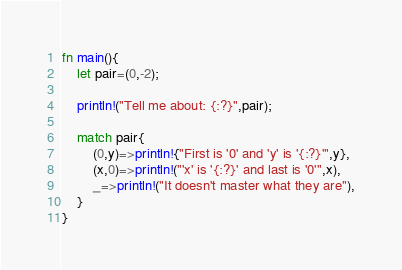<code> <loc_0><loc_0><loc_500><loc_500><_Rust_>fn main(){
    let pair=(0,-2);

    println!("Tell me about: {:?}",pair);

    match pair{
        (0,y)=>println!{"First is '0' and 'y' is '{:?}'",y},
        (x,0)=>println!("'x' is '{:?}' and last is '0'",x),
        _=>println!("It doesn't master what they are"),
    }
}</code> 